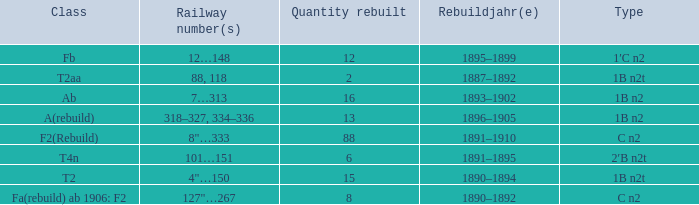What was the Rebuildjahr(e) for the T2AA class? 1887–1892. 